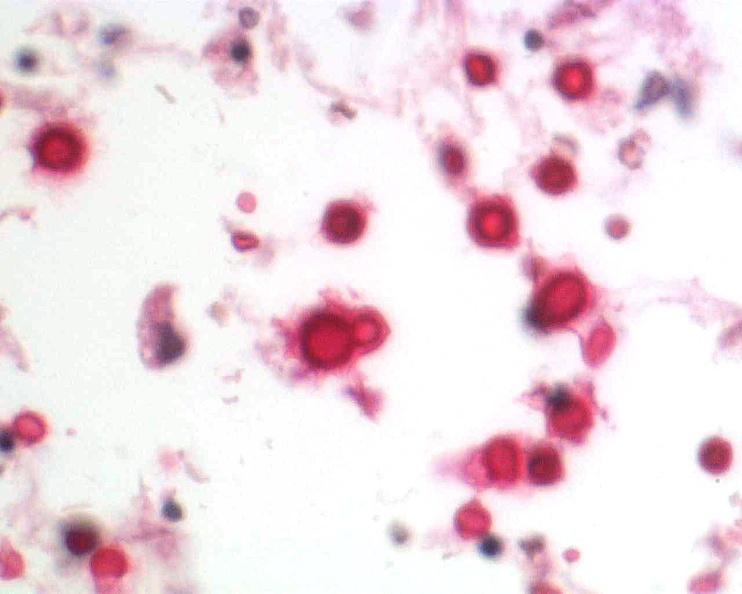where is this?
Answer the question using a single word or phrase. Nervous 